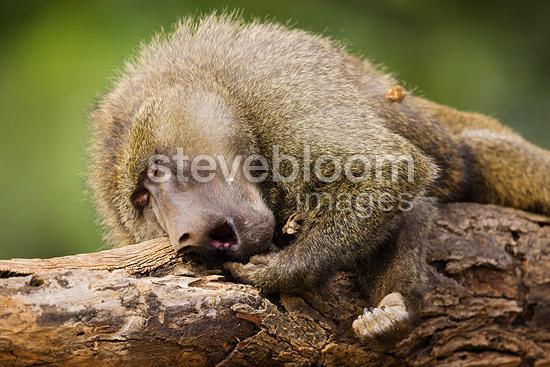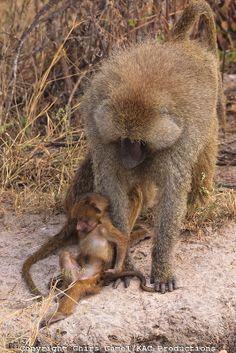The first image is the image on the left, the second image is the image on the right. For the images displayed, is the sentence "One of the images features two mandrils; mom and baby." factually correct? Answer yes or no. Yes. The first image is the image on the left, the second image is the image on the right. Assess this claim about the two images: "There is no more than one baboon in the left image.". Correct or not? Answer yes or no. Yes. 